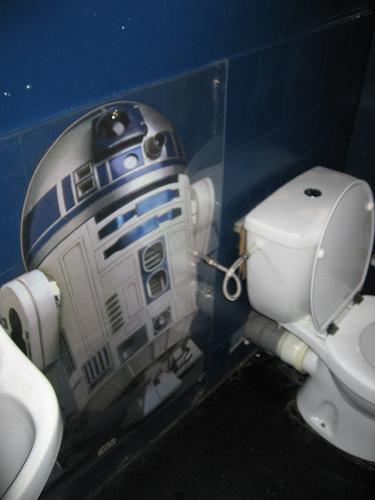How many toilets are in the bathroom?
Give a very brief answer. 1. How many robots can be seen?
Give a very brief answer. 1. 